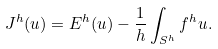<formula> <loc_0><loc_0><loc_500><loc_500>J ^ { h } ( u ) = E ^ { h } ( u ) - \frac { 1 } { h } \int _ { S ^ { h } } f ^ { h } u .</formula> 